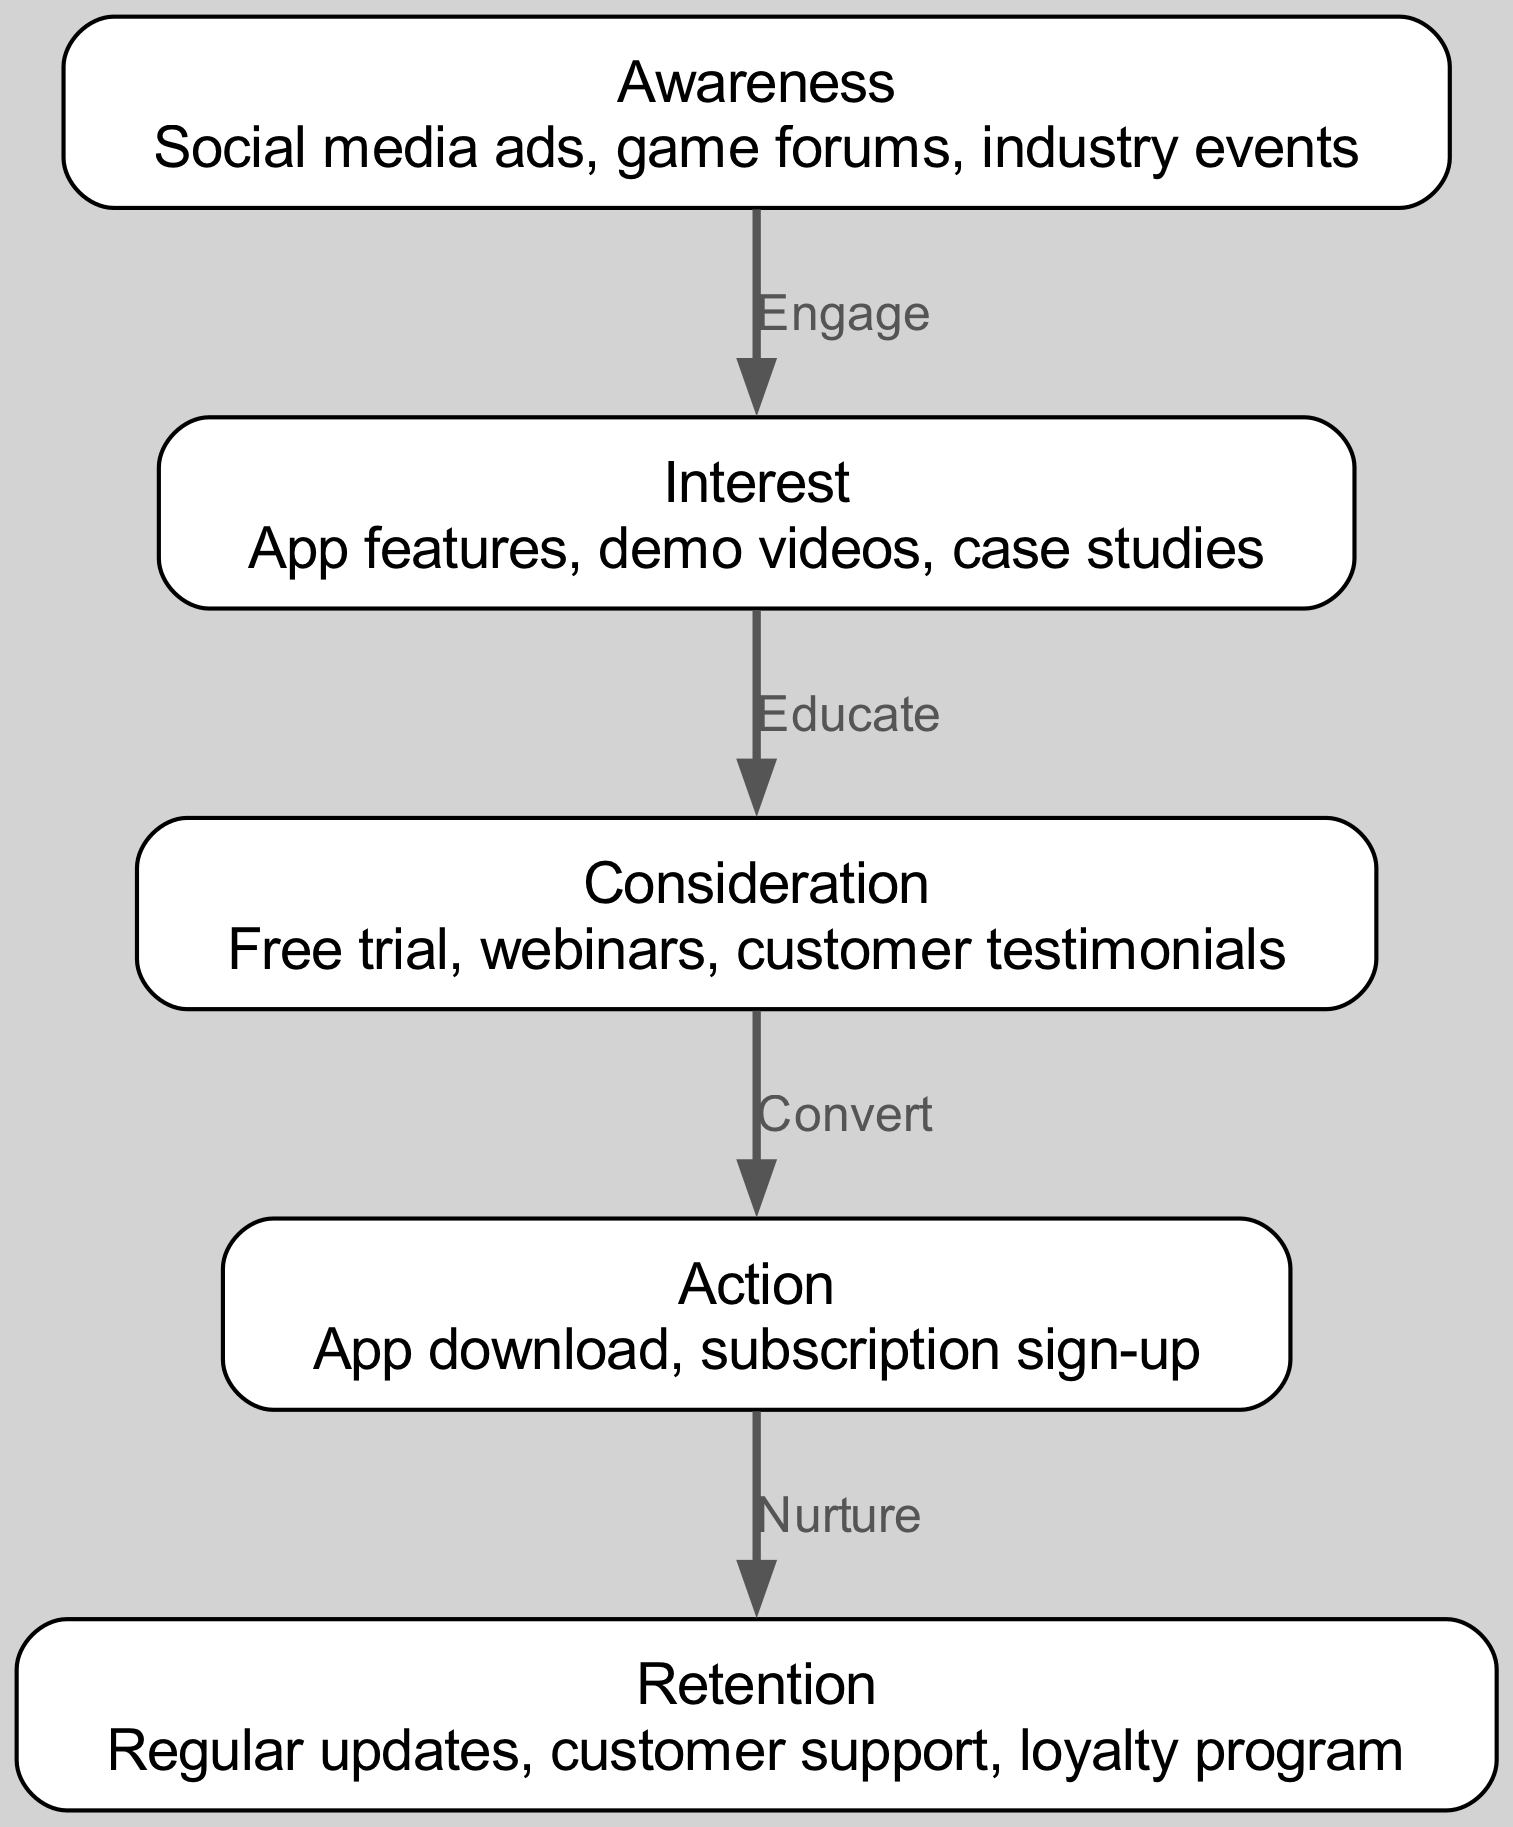What is the first node in the marketing funnel? The diagram begins with the "Awareness" node, which is the initial point of the marketing funnel before any engagement takes place.
Answer: Awareness How many nodes are present in the diagram? The diagram includes a total of five nodes: Awareness, Interest, Consideration, Action, and Retention.
Answer: Five What is the connection between "Interest" and "Consideration"? The connection between "Interest" and "Consideration" is labeled "Educate," indicating that educating potential users leads them from interest to consideration.
Answer: Educate Which node follows the "Action" node in the diagram? The "Retention" node follows the "Action" node, indicating that after taking action, the focus shifts to retaining users.
Answer: Retention What type of engagement occurs between "Awareness" and "Interest"? The engagement that occurs between "Awareness" and "Interest" is labeled as "Engage," which suggests that awareness leads to engagement with the app's features.
Answer: Engage What is the primary goal of the "Consideration" stage? The primary goal of the "Consideration" stage is to convert potential users into actual users, typically through offers like a free trial or customer testimonials.
Answer: Convert How many edges are in the diagram? There are a total of four edges in the diagram, illustrating the flow from awareness through to retention.
Answer: Four What action corresponds to the "Action" node? The action corresponding to the "Action" node includes the app download and subscription sign-up, as noted in the description of that node.
Answer: App download, subscription sign-up What is the purpose of the "Retention" stage? The purpose of the "Retention" stage is to keep users engaged through regular updates, customer support, and loyalty programs.
Answer: Loyalty program What educational methods are implied in the "Interest" to "Consideration" transition? The educational methods implied between "Interest" and "Consideration" include free trials, webinars, and customer testimonials aimed at informing potential users.
Answer: Educate 